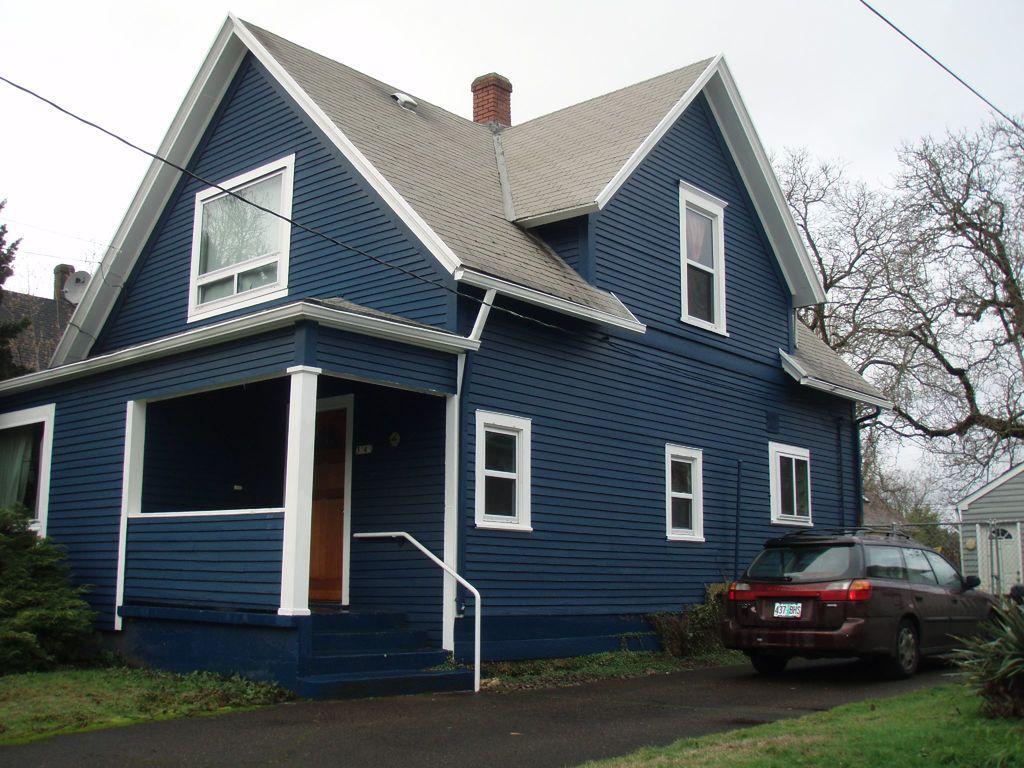How would you summarize this image in a sentence or two? This is the house with glass windows and a door. This house is blue in color. These are the stairs with the staircase holder. I can see the car, which is parked. These are the trees. These look like bushes. Here is the grass. This is the road. In the background, I can see another house. 